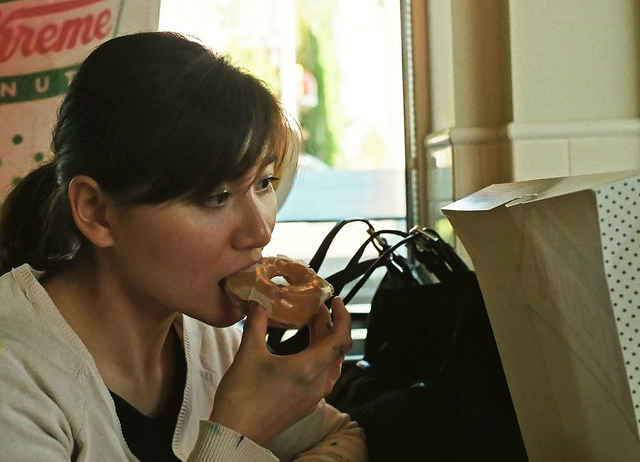Please transcribe the text in this image. NUT 